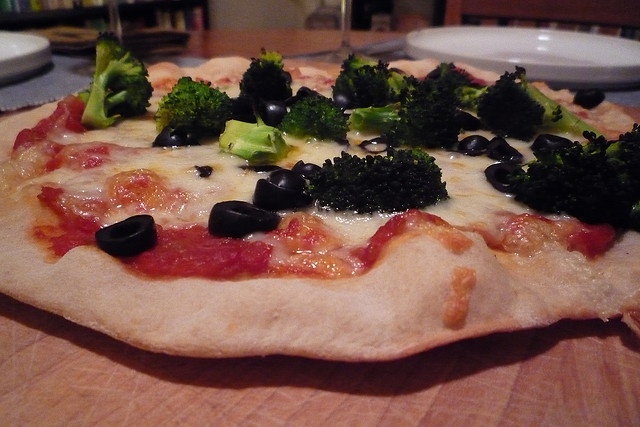Describe the objects in this image and their specific colors. I can see pizza in black, brown, and tan tones, dining table in black, brown, and maroon tones, broccoli in black, tan, gray, and darkgray tones, broccoli in black, darkgreen, and gray tones, and broccoli in black, darkgreen, and maroon tones in this image. 